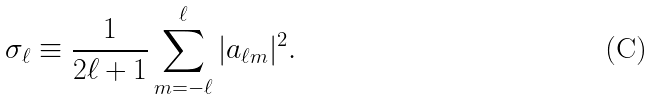<formula> <loc_0><loc_0><loc_500><loc_500>\sigma _ { \ell } \equiv \frac { 1 } { 2 \ell + 1 } \sum _ { m = - \ell } ^ { \ell } | a _ { \ell m } | ^ { 2 } .</formula> 